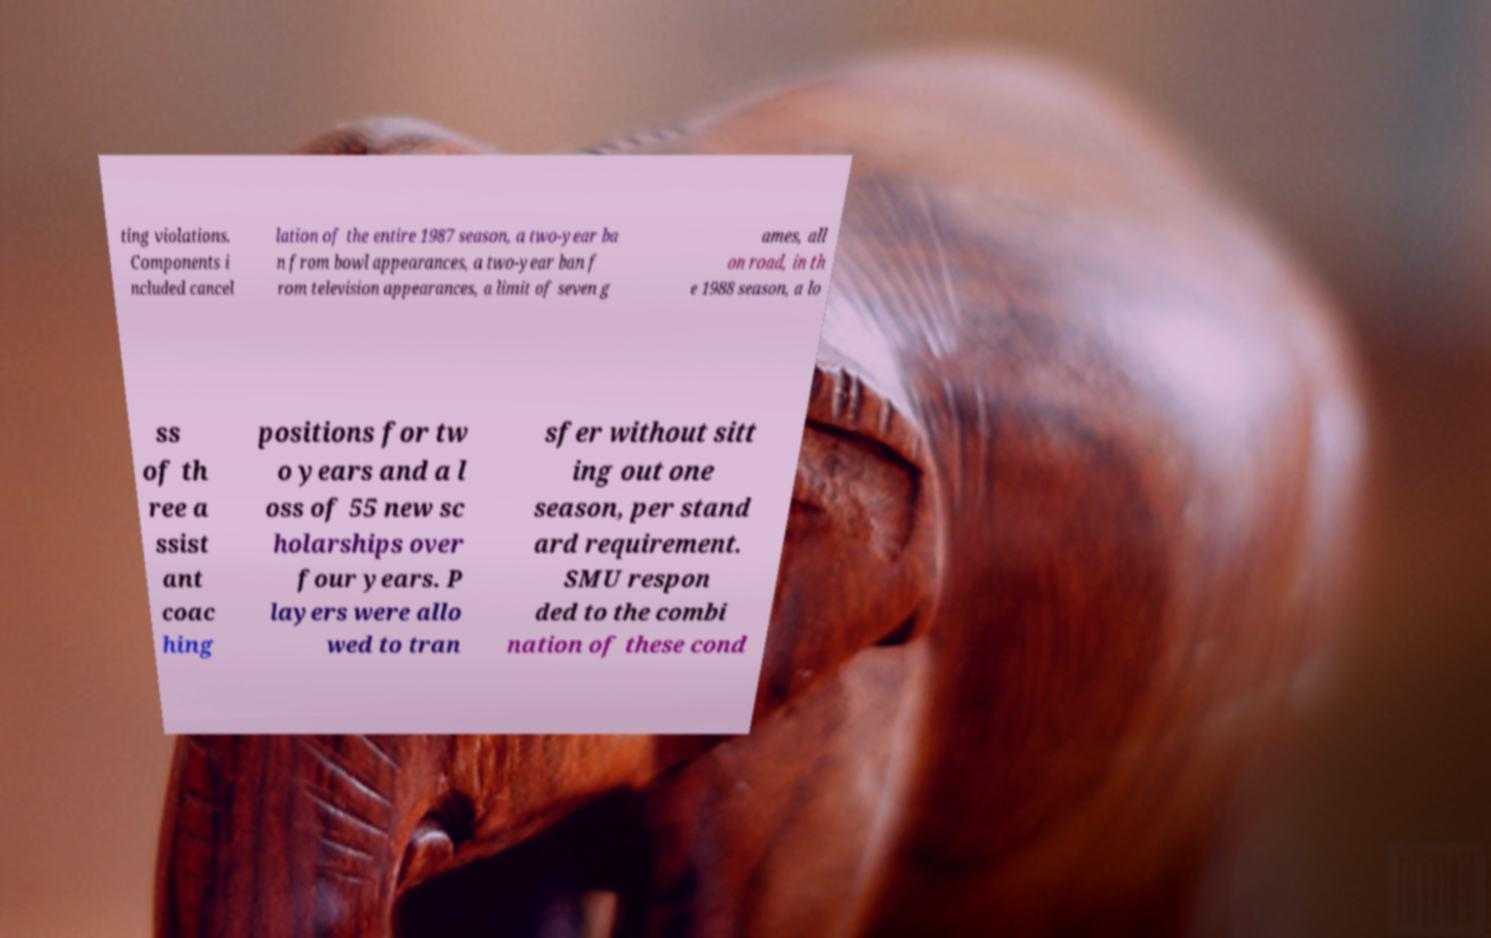Could you assist in decoding the text presented in this image and type it out clearly? ting violations. Components i ncluded cancel lation of the entire 1987 season, a two-year ba n from bowl appearances, a two-year ban f rom television appearances, a limit of seven g ames, all on road, in th e 1988 season, a lo ss of th ree a ssist ant coac hing positions for tw o years and a l oss of 55 new sc holarships over four years. P layers were allo wed to tran sfer without sitt ing out one season, per stand ard requirement. SMU respon ded to the combi nation of these cond 